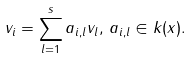Convert formula to latex. <formula><loc_0><loc_0><loc_500><loc_500>v _ { i } = \sum _ { l = 1 } ^ { s } a _ { i , l } v _ { l } , \, a _ { i , l } \in k ( x ) .</formula> 